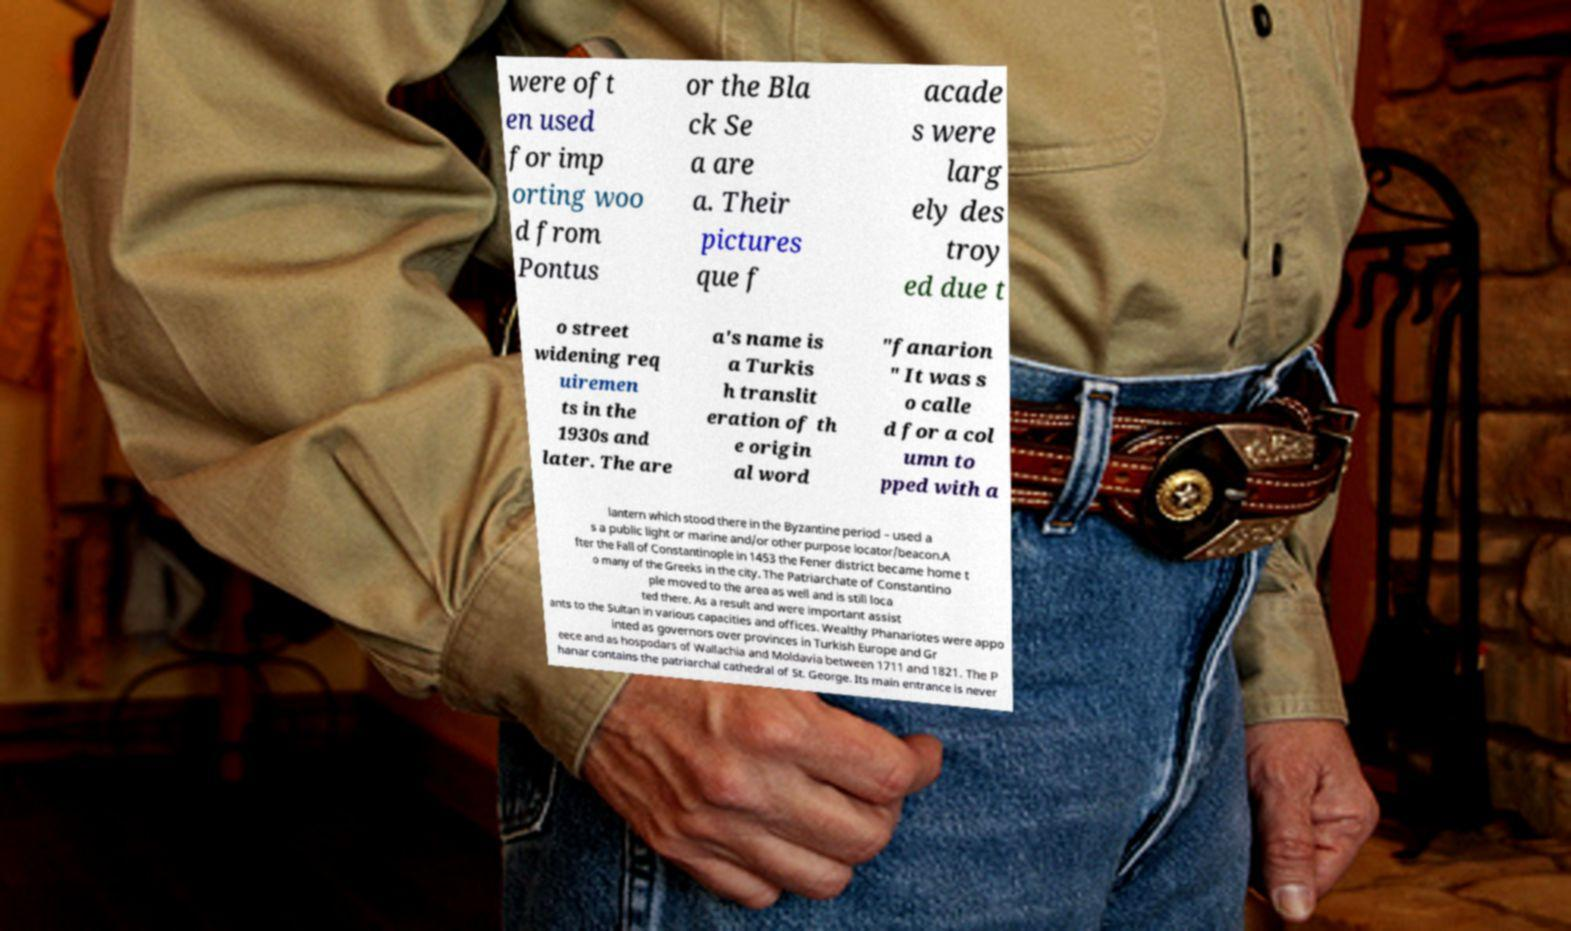There's text embedded in this image that I need extracted. Can you transcribe it verbatim? were oft en used for imp orting woo d from Pontus or the Bla ck Se a are a. Their pictures que f acade s were larg ely des troy ed due t o street widening req uiremen ts in the 1930s and later. The are a's name is a Turkis h translit eration of th e origin al word "fanarion " It was s o calle d for a col umn to pped with a lantern which stood there in the Byzantine period – used a s a public light or marine and/or other purpose locator/beacon.A fter the Fall of Constantinople in 1453 the Fener district became home t o many of the Greeks in the city. The Patriarchate of Constantino ple moved to the area as well and is still loca ted there. As a result and were important assist ants to the Sultan in various capacities and offices. Wealthy Phanariotes were appo inted as governors over provinces in Turkish Europe and Gr eece and as hospodars of Wallachia and Moldavia between 1711 and 1821. The P hanar contains the patriarchal cathedral of St. George. Its main entrance is never 